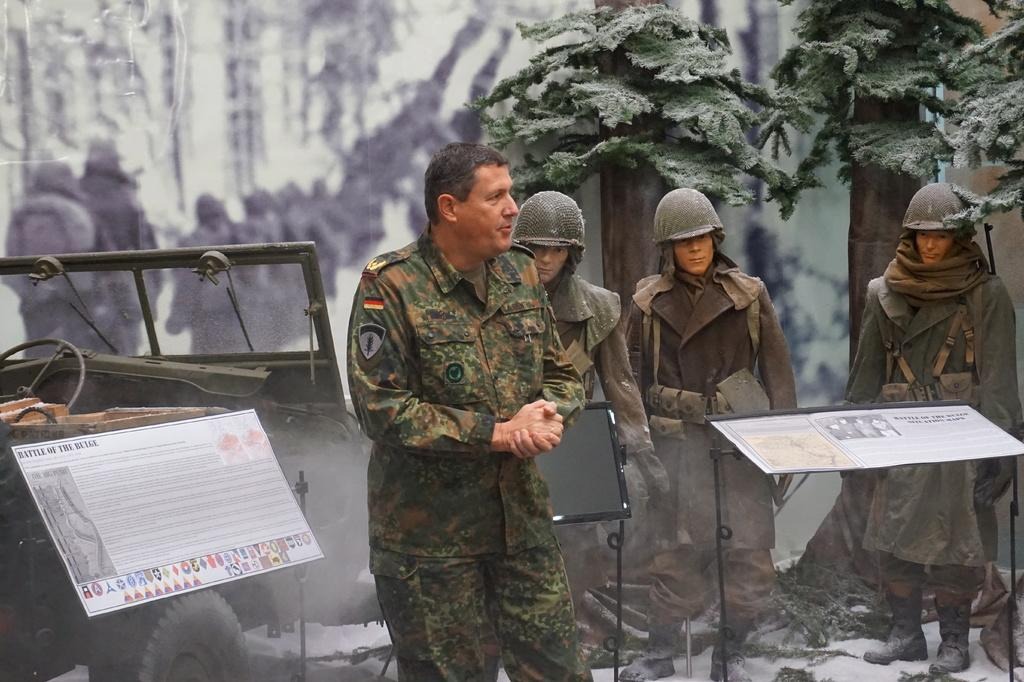What can be seen in the image? There are people standing in the image, along with snow, a vehicle, boards with stands, trees, and a blurry background with people visible in it. What is the weather like in the image? The presence of snow suggests that it is cold and possibly snowy in the image. What type of vehicle is in the image? The specific type of vehicle is not mentioned, but it is present in the image. What is the purpose of the boards with stands in the image? The purpose of the boards with stands is not clear from the provided facts, but they are visible in the image. What letter is the brother holding in the image? There is no brother or letter present in the image. What type of wilderness can be seen in the image? There is no wilderness visible in the image; it features people, snow, a vehicle, boards with stands, trees, and a blurry background with people visible in it. 